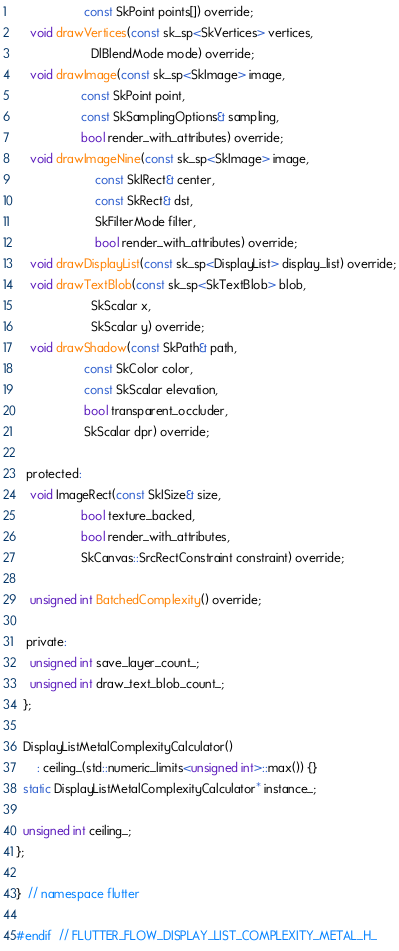<code> <loc_0><loc_0><loc_500><loc_500><_C_>                    const SkPoint points[]) override;
    void drawVertices(const sk_sp<SkVertices> vertices,
                      DlBlendMode mode) override;
    void drawImage(const sk_sp<SkImage> image,
                   const SkPoint point,
                   const SkSamplingOptions& sampling,
                   bool render_with_attributes) override;
    void drawImageNine(const sk_sp<SkImage> image,
                       const SkIRect& center,
                       const SkRect& dst,
                       SkFilterMode filter,
                       bool render_with_attributes) override;
    void drawDisplayList(const sk_sp<DisplayList> display_list) override;
    void drawTextBlob(const sk_sp<SkTextBlob> blob,
                      SkScalar x,
                      SkScalar y) override;
    void drawShadow(const SkPath& path,
                    const SkColor color,
                    const SkScalar elevation,
                    bool transparent_occluder,
                    SkScalar dpr) override;

   protected:
    void ImageRect(const SkISize& size,
                   bool texture_backed,
                   bool render_with_attributes,
                   SkCanvas::SrcRectConstraint constraint) override;

    unsigned int BatchedComplexity() override;

   private:
    unsigned int save_layer_count_;
    unsigned int draw_text_blob_count_;
  };

  DisplayListMetalComplexityCalculator()
      : ceiling_(std::numeric_limits<unsigned int>::max()) {}
  static DisplayListMetalComplexityCalculator* instance_;

  unsigned int ceiling_;
};

}  // namespace flutter

#endif  // FLUTTER_FLOW_DISPLAY_LIST_COMPLEXITY_METAL_H_
</code> 